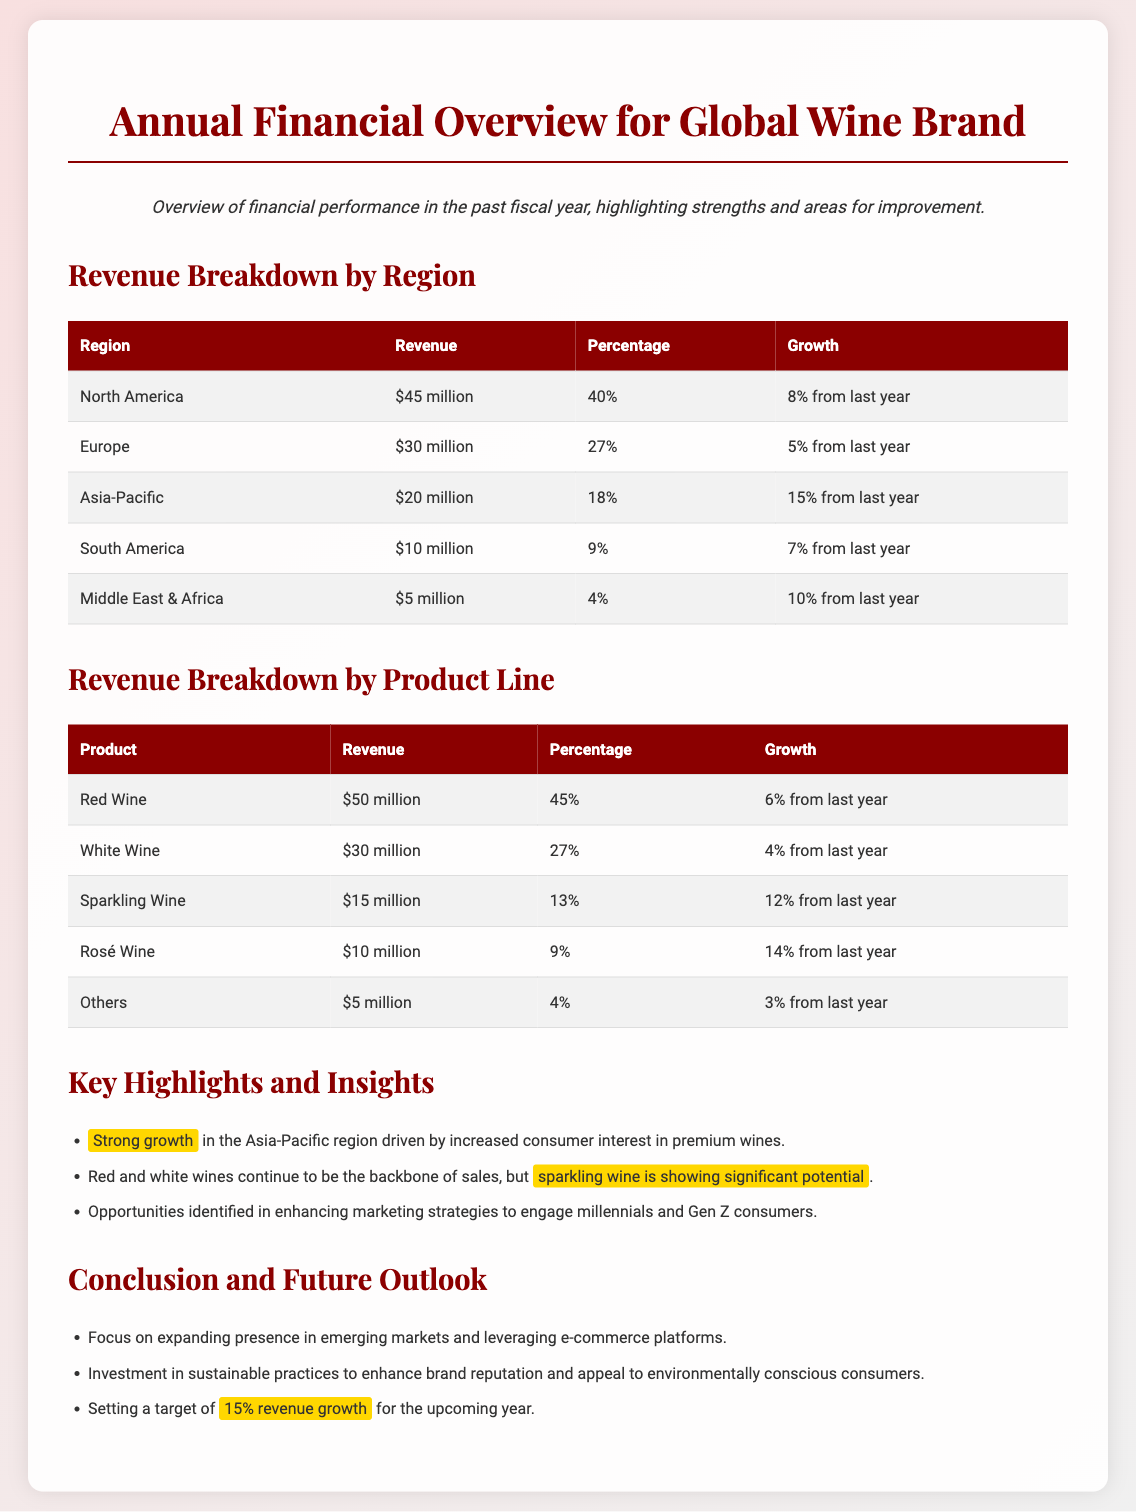What is the total revenue from North America? The total revenue from North America is stated in the document as $45 million.
Answer: $45 million Which product line generated the highest revenue? The product line with the highest revenue is Red Wine, with $50 million.
Answer: Red Wine What percentage of total revenue does the Asia-Pacific region represent? The document states that the Asia-Pacific region represents 18% of total revenue.
Answer: 18% How much revenue growth did South America experience? The revenue growth for South America is reported as 7% from last year.
Answer: 7% What is the revenue from Sparkling Wine? The revenue earned from Sparkling Wine is given as $15 million in the document.
Answer: $15 million Which region showed the strongest growth? The Asia-Pacific region is indicated as having strong growth of 15% from last year.
Answer: Asia-Pacific What is the revenue target for the upcoming year? The target revenue growth set for the upcoming year is 15%.
Answer: 15% What percentage of the total revenue comes from White Wine? White Wine comprises 27% of the total revenue according to the document.
Answer: 27% How much revenue does the Middle East & Africa region generate? The document states that the Middle East & Africa region generates $5 million in revenue.
Answer: $5 million 